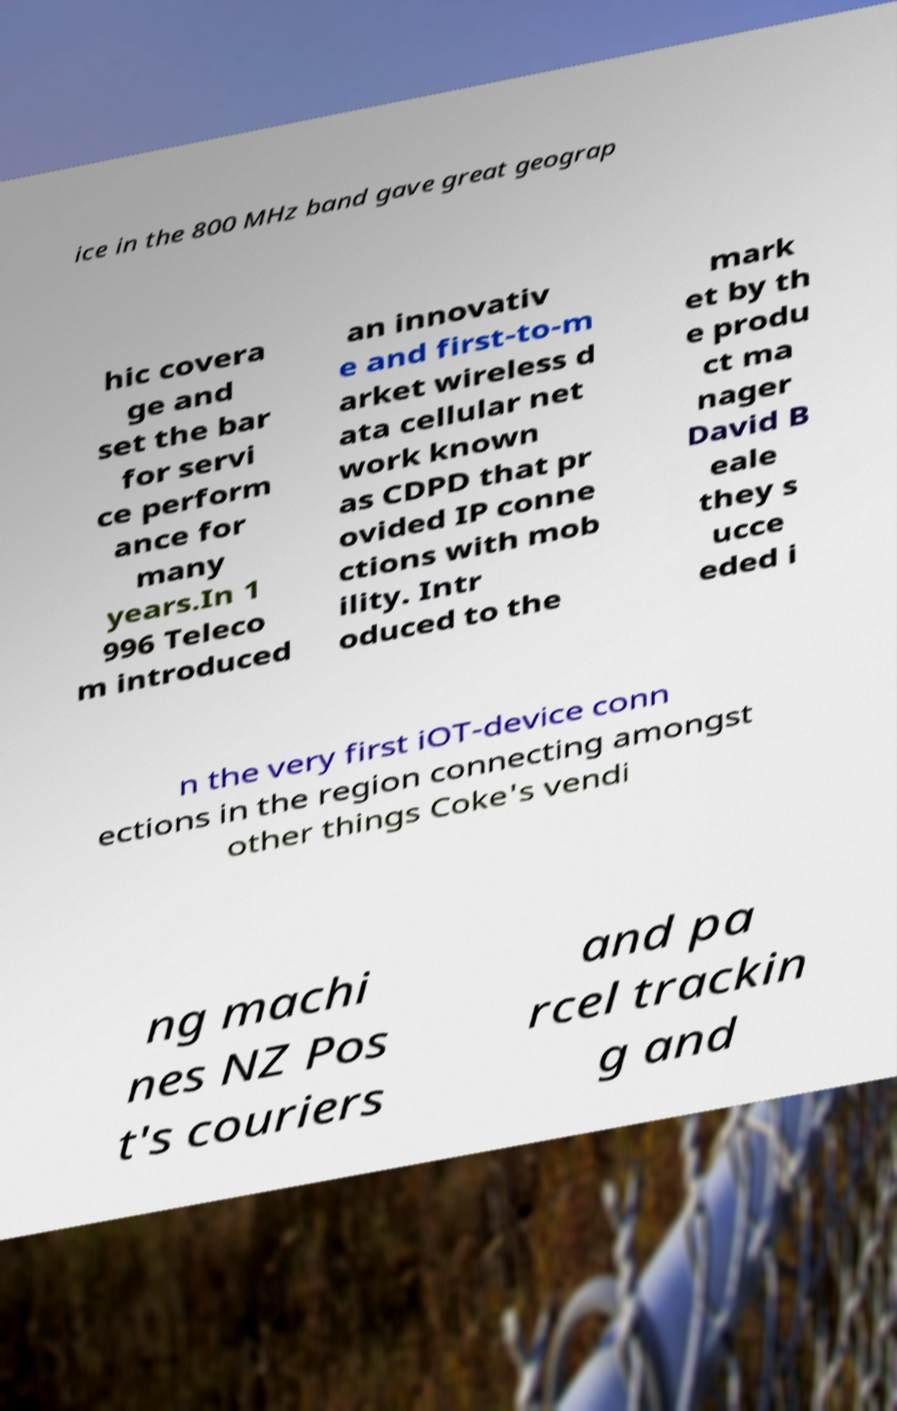Could you assist in decoding the text presented in this image and type it out clearly? ice in the 800 MHz band gave great geograp hic covera ge and set the bar for servi ce perform ance for many years.In 1 996 Teleco m introduced an innovativ e and first-to-m arket wireless d ata cellular net work known as CDPD that pr ovided IP conne ctions with mob ility. Intr oduced to the mark et by th e produ ct ma nager David B eale they s ucce eded i n the very first iOT-device conn ections in the region connecting amongst other things Coke's vendi ng machi nes NZ Pos t's couriers and pa rcel trackin g and 